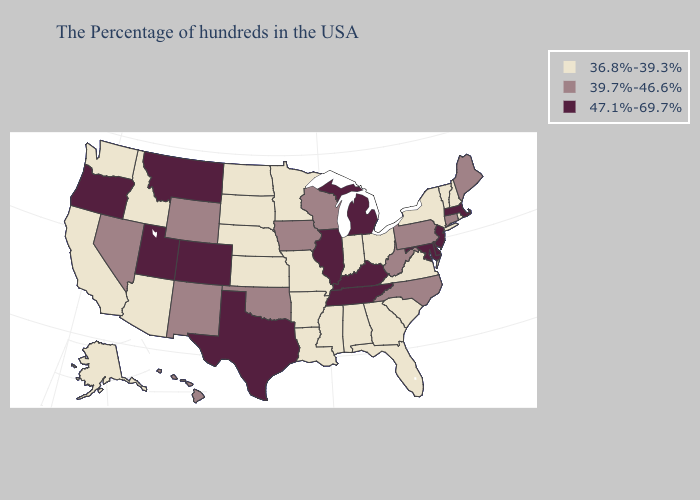What is the highest value in the South ?
Answer briefly. 47.1%-69.7%. What is the highest value in the USA?
Be succinct. 47.1%-69.7%. Does Maine have the lowest value in the Northeast?
Quick response, please. No. What is the value of South Dakota?
Answer briefly. 36.8%-39.3%. What is the lowest value in the MidWest?
Short answer required. 36.8%-39.3%. Does Florida have a lower value than New Jersey?
Keep it brief. Yes. What is the value of Idaho?
Write a very short answer. 36.8%-39.3%. What is the value of Nevada?
Concise answer only. 39.7%-46.6%. What is the highest value in states that border North Dakota?
Be succinct. 47.1%-69.7%. Name the states that have a value in the range 39.7%-46.6%?
Answer briefly. Maine, Connecticut, Pennsylvania, North Carolina, West Virginia, Wisconsin, Iowa, Oklahoma, Wyoming, New Mexico, Nevada, Hawaii. Which states have the highest value in the USA?
Give a very brief answer. Massachusetts, New Jersey, Delaware, Maryland, Michigan, Kentucky, Tennessee, Illinois, Texas, Colorado, Utah, Montana, Oregon. What is the value of Hawaii?
Keep it brief. 39.7%-46.6%. What is the lowest value in the South?
Answer briefly. 36.8%-39.3%. What is the value of Virginia?
Short answer required. 36.8%-39.3%. 